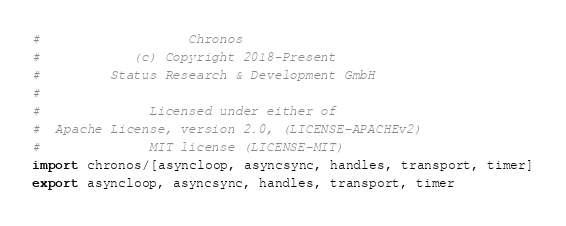<code> <loc_0><loc_0><loc_500><loc_500><_Nim_>#                   Chronos
#            (c) Copyright 2018-Present
#         Status Research & Development GmbH
#
#              Licensed under either of
#  Apache License, version 2.0, (LICENSE-APACHEv2)
#              MIT license (LICENSE-MIT)
import chronos/[asyncloop, asyncsync, handles, transport, timer]
export asyncloop, asyncsync, handles, transport, timer
</code> 